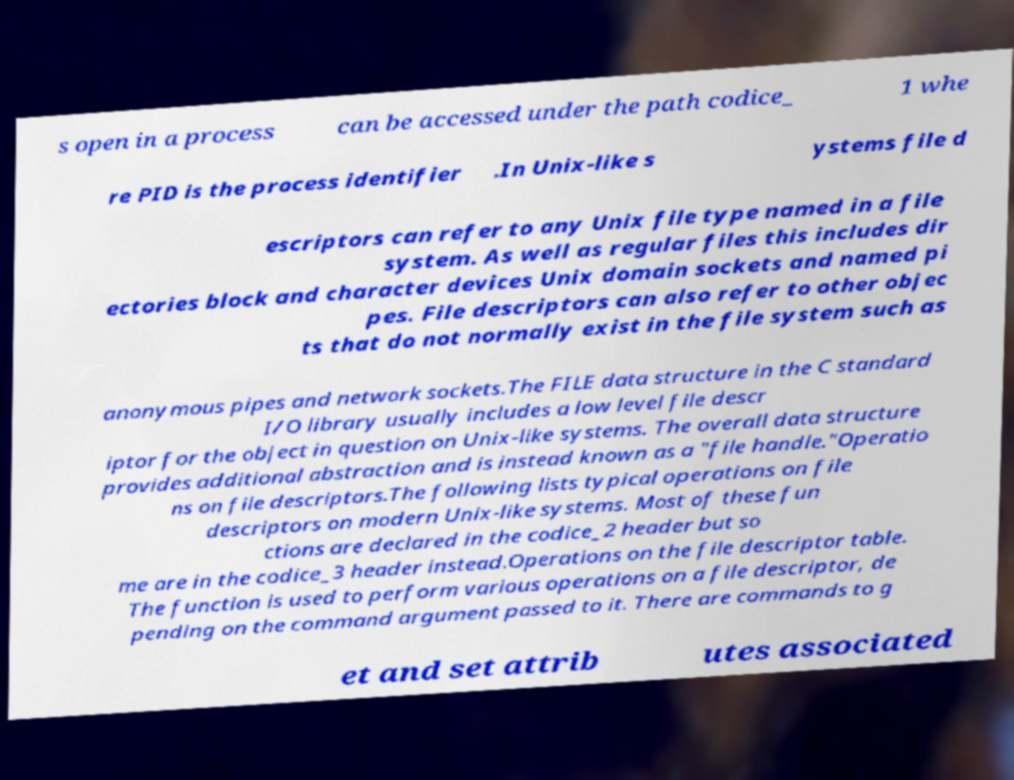Could you assist in decoding the text presented in this image and type it out clearly? s open in a process can be accessed under the path codice_ 1 whe re PID is the process identifier .In Unix-like s ystems file d escriptors can refer to any Unix file type named in a file system. As well as regular files this includes dir ectories block and character devices Unix domain sockets and named pi pes. File descriptors can also refer to other objec ts that do not normally exist in the file system such as anonymous pipes and network sockets.The FILE data structure in the C standard I/O library usually includes a low level file descr iptor for the object in question on Unix-like systems. The overall data structure provides additional abstraction and is instead known as a "file handle."Operatio ns on file descriptors.The following lists typical operations on file descriptors on modern Unix-like systems. Most of these fun ctions are declared in the codice_2 header but so me are in the codice_3 header instead.Operations on the file descriptor table. The function is used to perform various operations on a file descriptor, de pending on the command argument passed to it. There are commands to g et and set attrib utes associated 